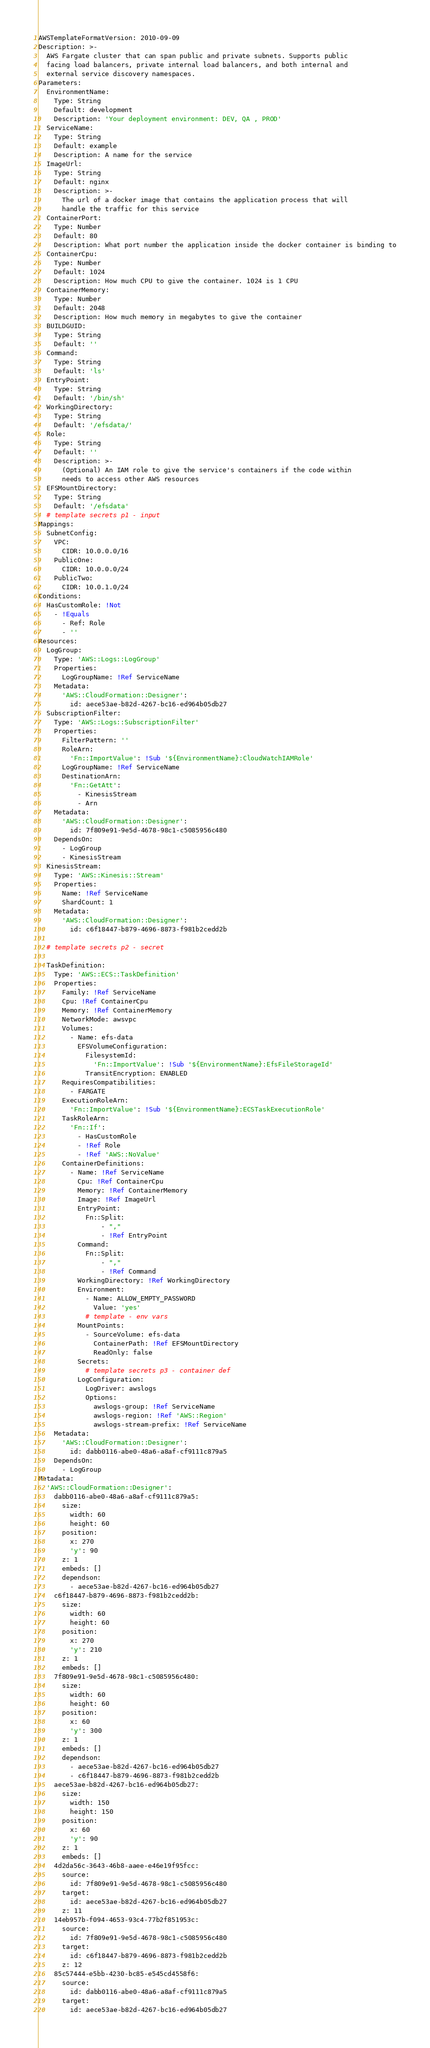<code> <loc_0><loc_0><loc_500><loc_500><_YAML_>AWSTemplateFormatVersion: 2010-09-09
Description: >-
  AWS Fargate cluster that can span public and private subnets. Supports public
  facing load balancers, private internal load balancers, and both internal and
  external service discovery namespaces.
Parameters:
  EnvironmentName:
    Type: String
    Default: development
    Description: 'Your deployment environment: DEV, QA , PROD'
  ServiceName:
    Type: String
    Default: example
    Description: A name for the service
  ImageUrl:
    Type: String
    Default: nginx
    Description: >-
      The url of a docker image that contains the application process that will
      handle the traffic for this service
  ContainerPort:
    Type: Number
    Default: 80
    Description: What port number the application inside the docker container is binding to
  ContainerCpu:
    Type: Number
    Default: 1024
    Description: How much CPU to give the container. 1024 is 1 CPU
  ContainerMemory:
    Type: Number
    Default: 2048
    Description: How much memory in megabytes to give the container
  BUILDGUID:
    Type: String
    Default: ''
  Command:
    Type: String
    Default: 'ls'
  EntryPoint:
    Type: String
    Default: '/bin/sh'
  WorkingDirectory:
    Type: String
    Default: '/efsdata/'
  Role:
    Type: String
    Default: ''
    Description: >-
      (Optional) An IAM role to give the service's containers if the code within
      needs to access other AWS resources
  EFSMountDirectory:
    Type: String
    Default: '/efsdata'
  # template secrets p1 - input
Mappings:
  SubnetConfig:
    VPC:
      CIDR: 10.0.0.0/16
    PublicOne:
      CIDR: 10.0.0.0/24
    PublicTwo:
      CIDR: 10.0.1.0/24
Conditions:
  HasCustomRole: !Not
    - !Equals
      - Ref: Role
      - ''
Resources:
  LogGroup:
    Type: 'AWS::Logs::LogGroup'
    Properties:
      LogGroupName: !Ref ServiceName
    Metadata:
      'AWS::CloudFormation::Designer':
        id: aece53ae-b82d-4267-bc16-ed964b05db27
  SubscriptionFilter:
    Type: 'AWS::Logs::SubscriptionFilter'
    Properties:
      FilterPattern: ''
      RoleArn:
        'Fn::ImportValue': !Sub '${EnvironmentName}:CloudWatchIAMRole'
      LogGroupName: !Ref ServiceName
      DestinationArn:
        'Fn::GetAtt':
          - KinesisStream
          - Arn
    Metadata:
      'AWS::CloudFormation::Designer':
        id: 7f809e91-9e5d-4678-98c1-c5085956c480
    DependsOn:
      - LogGroup
      - KinesisStream
  KinesisStream:
    Type: 'AWS::Kinesis::Stream'
    Properties:
      Name: !Ref ServiceName
      ShardCount: 1
    Metadata:
      'AWS::CloudFormation::Designer':
        id: c6f18447-b879-4696-8873-f981b2cedd2b

  # template secrets p2 - secret

  TaskDefinition:
    Type: 'AWS::ECS::TaskDefinition'
    Properties:
      Family: !Ref ServiceName
      Cpu: !Ref ContainerCpu
      Memory: !Ref ContainerMemory
      NetworkMode: awsvpc
      Volumes:
        - Name: efs-data
          EFSVolumeConfiguration:
            FilesystemId:
              'Fn::ImportValue': !Sub '${EnvironmentName}:EfsFileStorageId'
            TransitEncryption: ENABLED
      RequiresCompatibilities:
        - FARGATE
      ExecutionRoleArn:
        'Fn::ImportValue': !Sub '${EnvironmentName}:ECSTaskExecutionRole'
      TaskRoleArn:
        'Fn::If':
          - HasCustomRole
          - !Ref Role
          - !Ref 'AWS::NoValue'
      ContainerDefinitions:
        - Name: !Ref ServiceName
          Cpu: !Ref ContainerCpu
          Memory: !Ref ContainerMemory
          Image: !Ref ImageUrl
          EntryPoint:
            Fn::Split:
                - ","
                - !Ref EntryPoint
          Command:
            Fn::Split:
                - ","
                - !Ref Command
          WorkingDirectory: !Ref WorkingDirectory
          Environment:
            - Name: ALLOW_EMPTY_PASSWORD
              Value: 'yes'
            # template - env vars
          MountPoints:
            - SourceVolume: efs-data
              ContainerPath: !Ref EFSMountDirectory
              ReadOnly: false
          Secrets:
            # template secrets p3 - container def
          LogConfiguration:
            LogDriver: awslogs
            Options:
              awslogs-group: !Ref ServiceName
              awslogs-region: !Ref 'AWS::Region'
              awslogs-stream-prefix: !Ref ServiceName
    Metadata:
      'AWS::CloudFormation::Designer':
        id: dabb0116-abe0-48a6-a8af-cf9111c879a5
    DependsOn:
      - LogGroup
Metadata:
  'AWS::CloudFormation::Designer':
    dabb0116-abe0-48a6-a8af-cf9111c879a5:
      size:
        width: 60
        height: 60
      position:
        x: 270
        'y': 90
      z: 1
      embeds: []
      dependson:
        - aece53ae-b82d-4267-bc16-ed964b05db27
    c6f18447-b879-4696-8873-f981b2cedd2b:
      size:
        width: 60
        height: 60
      position:
        x: 270
        'y': 210
      z: 1
      embeds: []
    7f809e91-9e5d-4678-98c1-c5085956c480:
      size:
        width: 60
        height: 60
      position:
        x: 60
        'y': 300
      z: 1
      embeds: []
      dependson:
        - aece53ae-b82d-4267-bc16-ed964b05db27
        - c6f18447-b879-4696-8873-f981b2cedd2b
    aece53ae-b82d-4267-bc16-ed964b05db27:
      size:
        width: 150
        height: 150
      position:
        x: 60
        'y': 90
      z: 1
      embeds: []
    4d2da56c-3643-46b8-aaee-e46e19f95fcc:
      source:
        id: 7f809e91-9e5d-4678-98c1-c5085956c480
      target:
        id: aece53ae-b82d-4267-bc16-ed964b05db27
      z: 11
    14eb957b-f094-4653-93c4-77b2f851953c:
      source:
        id: 7f809e91-9e5d-4678-98c1-c5085956c480
      target:
        id: c6f18447-b879-4696-8873-f981b2cedd2b
      z: 12
    85c57444-e5bb-4230-bc85-e545cd4558f6:
      source:
        id: dabb0116-abe0-48a6-a8af-cf9111c879a5
      target:
        id: aece53ae-b82d-4267-bc16-ed964b05db27</code> 